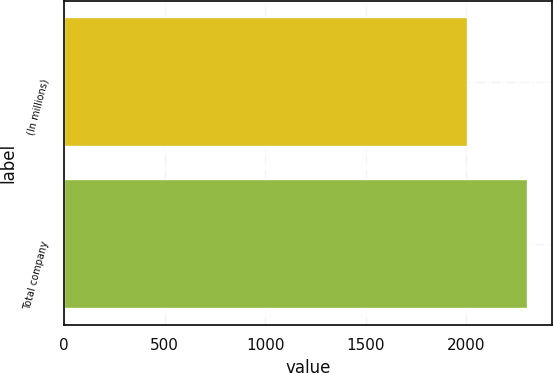Convert chart to OTSL. <chart><loc_0><loc_0><loc_500><loc_500><bar_chart><fcel>(In millions)<fcel>Total company<nl><fcel>2009<fcel>2308<nl></chart> 